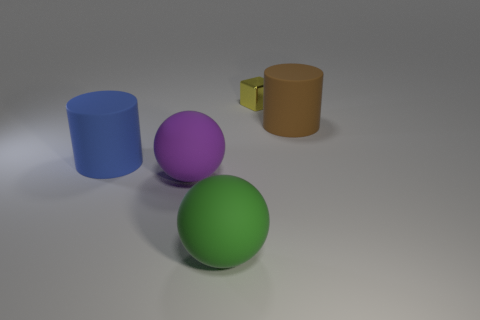There is another ball that is made of the same material as the purple ball; what is its size?
Ensure brevity in your answer.  Large. Is the number of tiny metallic blocks greater than the number of large gray cylinders?
Make the answer very short. Yes. What is the color of the matte cylinder left of the brown thing?
Your answer should be very brief. Blue. There is a thing that is both behind the large purple thing and to the left of the tiny yellow thing; how big is it?
Your answer should be compact. Large. What number of yellow metallic cylinders are the same size as the purple thing?
Offer a very short reply. 0. There is a brown thing that is the same shape as the blue object; what is its material?
Make the answer very short. Rubber. Is the yellow metallic object the same shape as the large green thing?
Make the answer very short. No. There is a small yellow object; how many yellow shiny things are to the left of it?
Offer a very short reply. 0. The green matte thing that is in front of the large object that is on the left side of the purple object is what shape?
Ensure brevity in your answer.  Sphere. What shape is the large green object that is the same material as the purple object?
Provide a succinct answer. Sphere. 